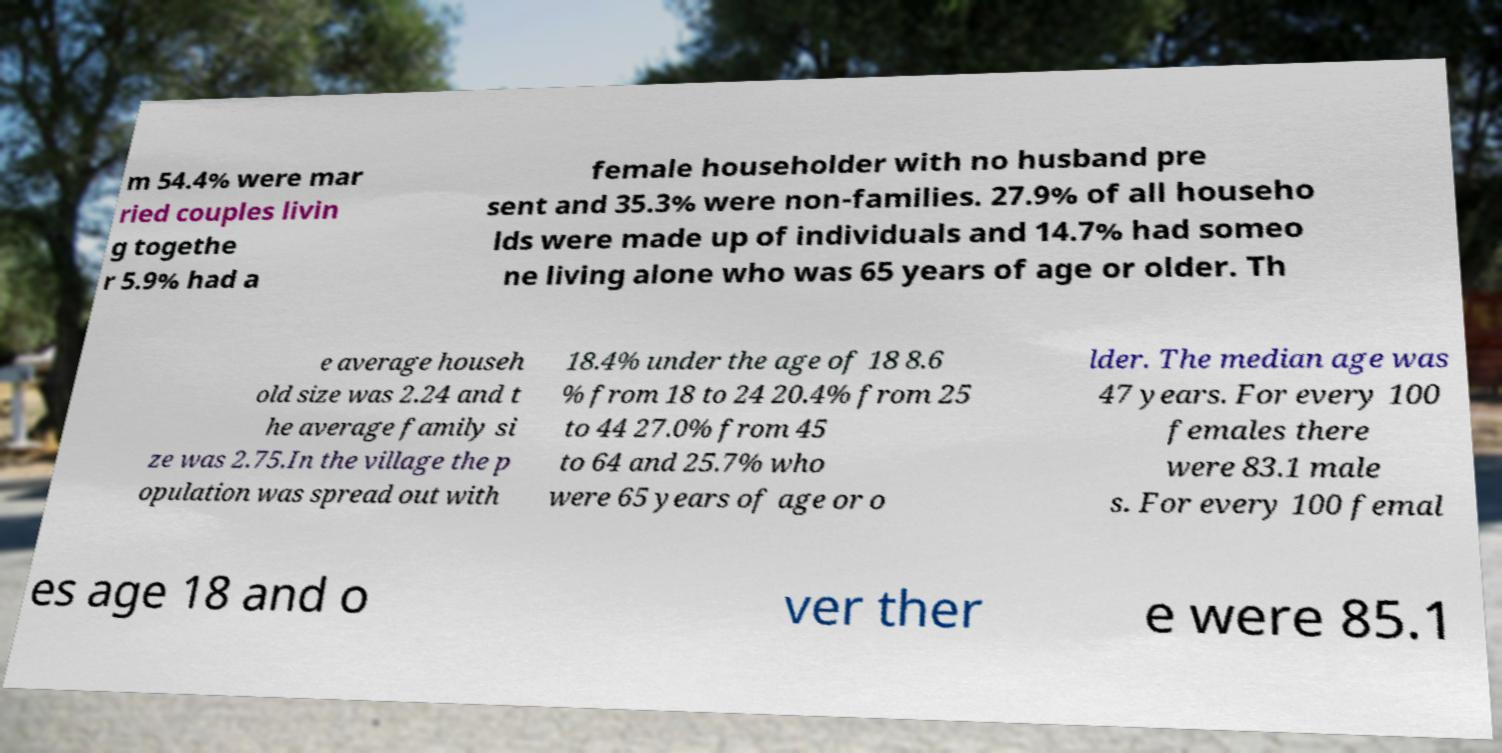Please read and relay the text visible in this image. What does it say? m 54.4% were mar ried couples livin g togethe r 5.9% had a female householder with no husband pre sent and 35.3% were non-families. 27.9% of all househo lds were made up of individuals and 14.7% had someo ne living alone who was 65 years of age or older. Th e average househ old size was 2.24 and t he average family si ze was 2.75.In the village the p opulation was spread out with 18.4% under the age of 18 8.6 % from 18 to 24 20.4% from 25 to 44 27.0% from 45 to 64 and 25.7% who were 65 years of age or o lder. The median age was 47 years. For every 100 females there were 83.1 male s. For every 100 femal es age 18 and o ver ther e were 85.1 